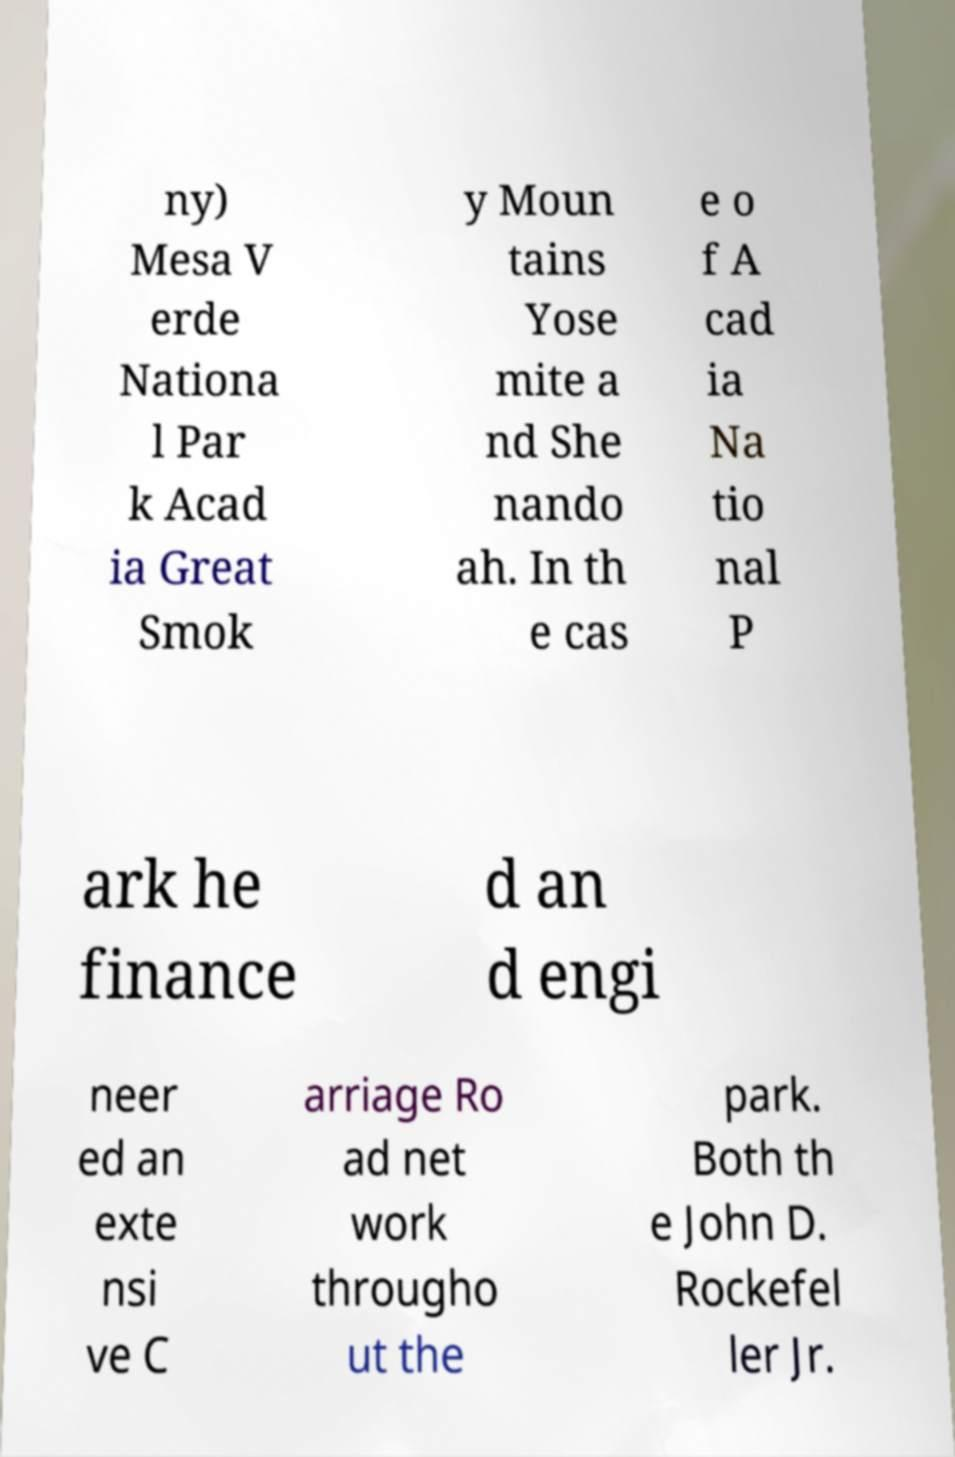I need the written content from this picture converted into text. Can you do that? ny) Mesa V erde Nationa l Par k Acad ia Great Smok y Moun tains Yose mite a nd She nando ah. In th e cas e o f A cad ia Na tio nal P ark he finance d an d engi neer ed an exte nsi ve C arriage Ro ad net work througho ut the park. Both th e John D. Rockefel ler Jr. 